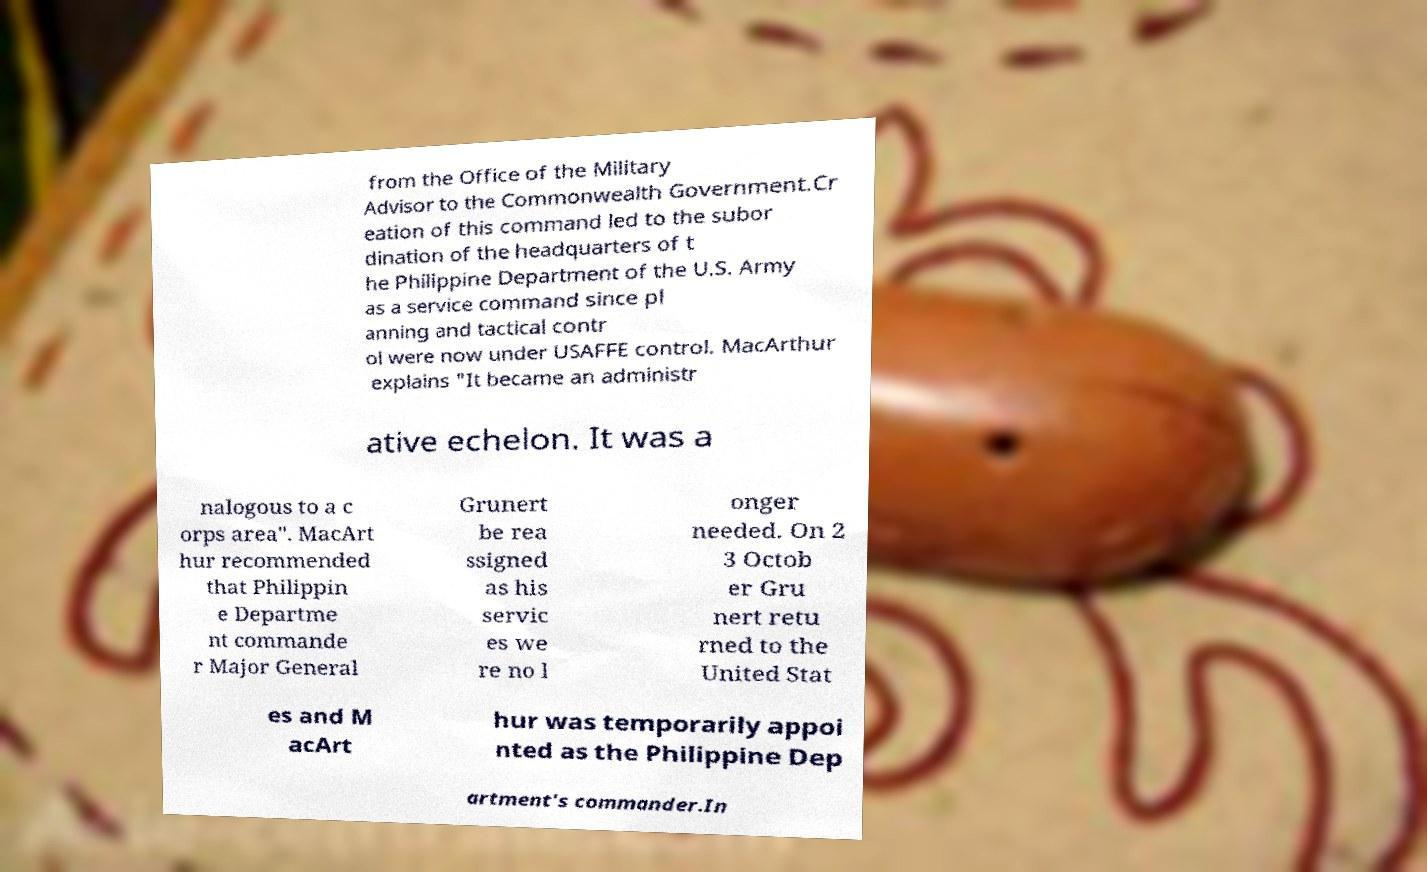For documentation purposes, I need the text within this image transcribed. Could you provide that? from the Office of the Military Advisor to the Commonwealth Government.Cr eation of this command led to the subor dination of the headquarters of t he Philippine Department of the U.S. Army as a service command since pl anning and tactical contr ol were now under USAFFE control. MacArthur explains "It became an administr ative echelon. It was a nalogous to a c orps area". MacArt hur recommended that Philippin e Departme nt commande r Major General Grunert be rea ssigned as his servic es we re no l onger needed. On 2 3 Octob er Gru nert retu rned to the United Stat es and M acArt hur was temporarily appoi nted as the Philippine Dep artment's commander.In 